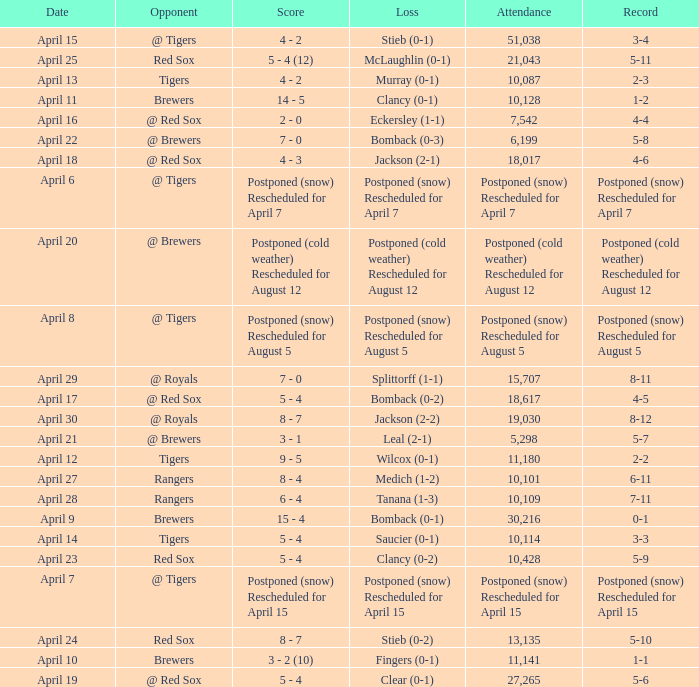What was the date for the game that had an attendance of 10,101? April 27. 